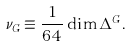Convert formula to latex. <formula><loc_0><loc_0><loc_500><loc_500>\nu _ { G } \equiv \frac { 1 } { 6 4 } \dim \Delta ^ { G } .</formula> 